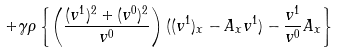Convert formula to latex. <formula><loc_0><loc_0><loc_500><loc_500>+ \gamma \rho \left \{ \left ( \frac { ( v ^ { 1 } ) ^ { 2 } + ( v ^ { 0 } ) ^ { 2 } } { v ^ { 0 } } \right ) ( ( v ^ { 1 } ) _ { x } - A _ { x } v ^ { 1 } ) - \frac { v ^ { 1 } } { v ^ { 0 } } A _ { x } \right \}</formula> 